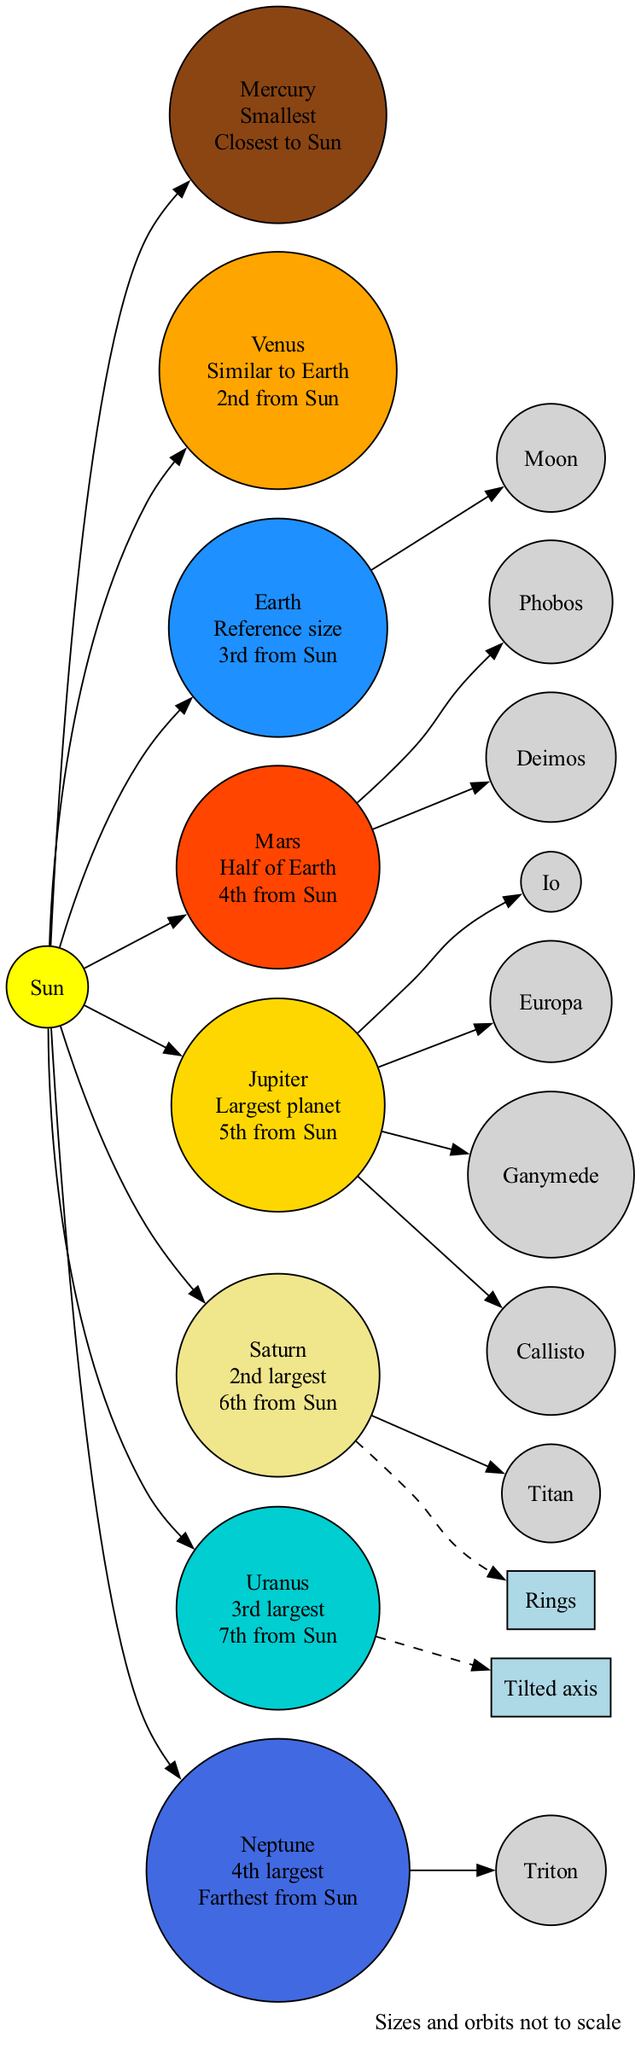What is the largest planet in the Solar System? Jupiter is labeled in the diagram as the largest planet. It is indicated alongside its position in the Solar System, which is the 5th from the Sun.
Answer: Jupiter What is the distance of Earth from the Sun? Earth is labeled as the 3rd planet from the Sun in the diagram. This information shows its relative distance in the context of the Solar System's arrangement.
Answer: 3rd from Sun How many moons does Mars have? The diagram shows that Mars has two moons, Phobos and Deimos. This information is presented alongside the Mars label in the diagram.
Answer: 2 moons Which planet has rings? Saturn is identified in the diagram with a special feature indicating it has rings. This is clearly marked to show a unique characteristic of that planet.
Answer: Saturn Which planet is closest to the Sun? Mercury is indicated as the closest planet to the Sun in the diagram. It is the first planet listed in the solar system's arrangement, confirming its proximity.
Answer: Mercury Which planet is tilted on its axis? Uranus is identified in the diagram as having a tilted axis. This feature is mentioned specifically next to Uranus in its labeling.
Answer: Uranus How many major moons does Jupiter have? The diagram indicates that Jupiter has four major moons: Io, Europa, Ganymede, and Callisto. This is presented alongside Jupiter in the diagram.
Answer: 4 moons What color is the Sun represented in the diagram? The Sun is represented in the diagram using a yellow color, which is indicated in the graphical representation of the Sun's node.
Answer: Yellow Which is the second-largest planet in the Solar System? Saturn is marked as the second largest planet in the diagram, where its size is compared among the other planets.
Answer: Saturn 